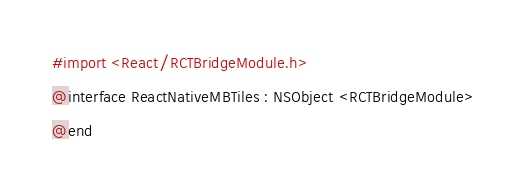<code> <loc_0><loc_0><loc_500><loc_500><_C_>#import <React/RCTBridgeModule.h>

@interface ReactNativeMBTiles : NSObject <RCTBridgeModule>

@end
</code> 